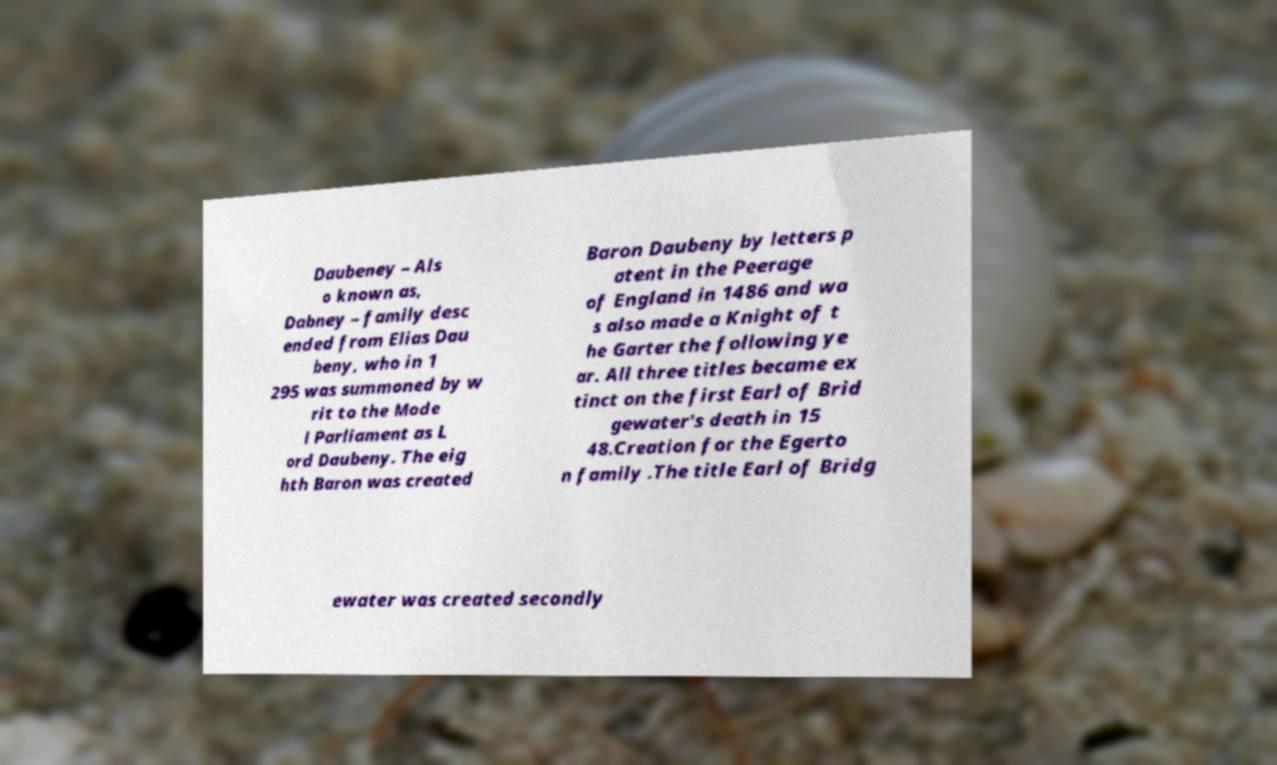Can you accurately transcribe the text from the provided image for me? Daubeney – Als o known as, Dabney – family desc ended from Elias Dau beny, who in 1 295 was summoned by w rit to the Mode l Parliament as L ord Daubeny. The eig hth Baron was created Baron Daubeny by letters p atent in the Peerage of England in 1486 and wa s also made a Knight of t he Garter the following ye ar. All three titles became ex tinct on the first Earl of Brid gewater's death in 15 48.Creation for the Egerto n family .The title Earl of Bridg ewater was created secondly 